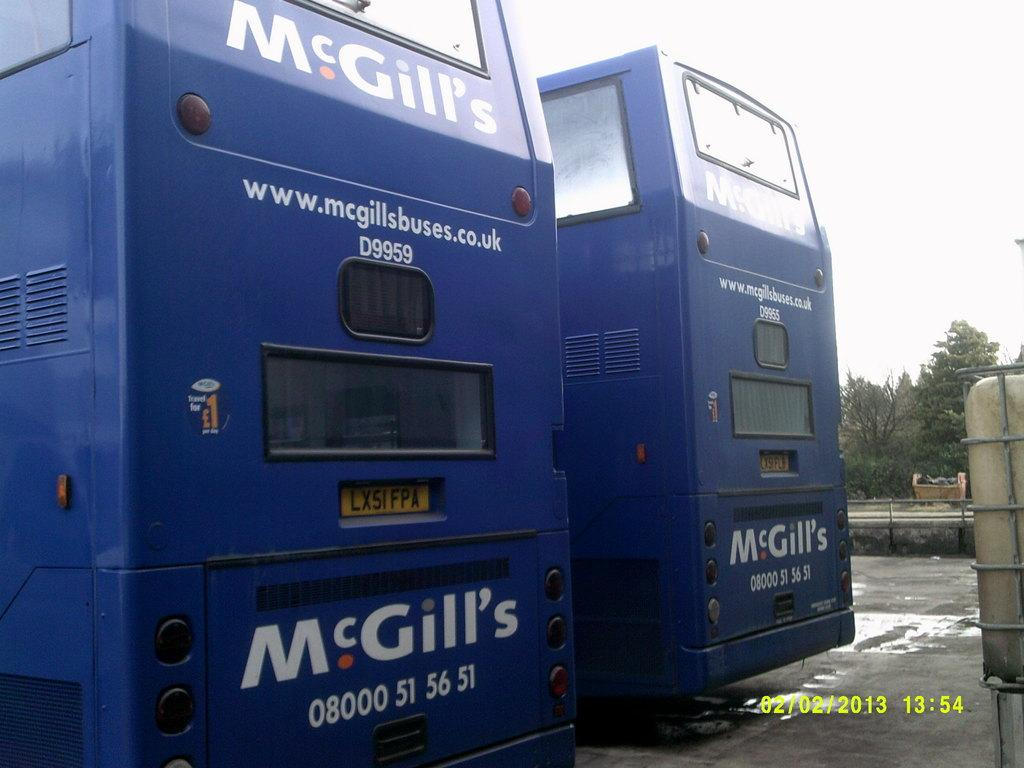What type of vehicles can be seen on the road in the image? There are two blue color vehicles on the road. What is the color of the object to the right in the image? The object to the right is ash color. What can be seen in the background of the image? There are many trees in the background. What is the color of the sky in the image? The sky is white in the image. What type of creature is holding a yoke in the image? There is no creature holding a yoke in the image. What type of bread can be seen in the image? There is no bread present in the image. 